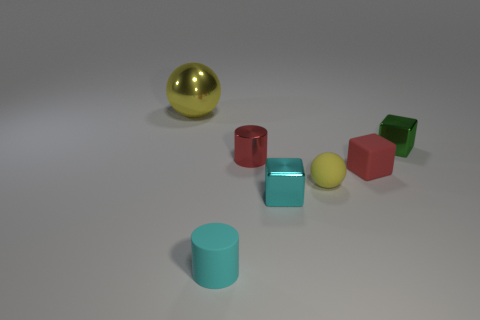Add 3 cyan matte objects. How many objects exist? 10 Subtract all balls. How many objects are left? 5 Add 6 big shiny objects. How many big shiny objects are left? 7 Add 3 brown cylinders. How many brown cylinders exist? 3 Subtract 0 gray balls. How many objects are left? 7 Subtract all tiny red metal spheres. Subtract all metal cubes. How many objects are left? 5 